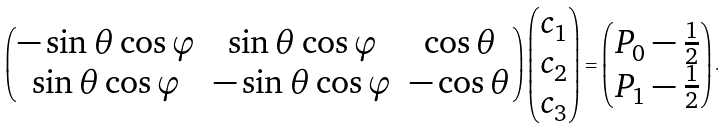Convert formula to latex. <formula><loc_0><loc_0><loc_500><loc_500>\begin{pmatrix} - \sin \theta \cos \varphi & \sin \theta \cos \varphi & \cos \theta \\ \sin \theta \cos \varphi & - \sin \theta \cos \varphi & - \cos \theta \end{pmatrix} \begin{pmatrix} c _ { 1 } \\ c _ { 2 } \\ c _ { 3 } \end{pmatrix} = \begin{pmatrix} P _ { 0 } - \frac { 1 } { 2 } \\ P _ { 1 } - \frac { 1 } { 2 } \end{pmatrix} .</formula> 